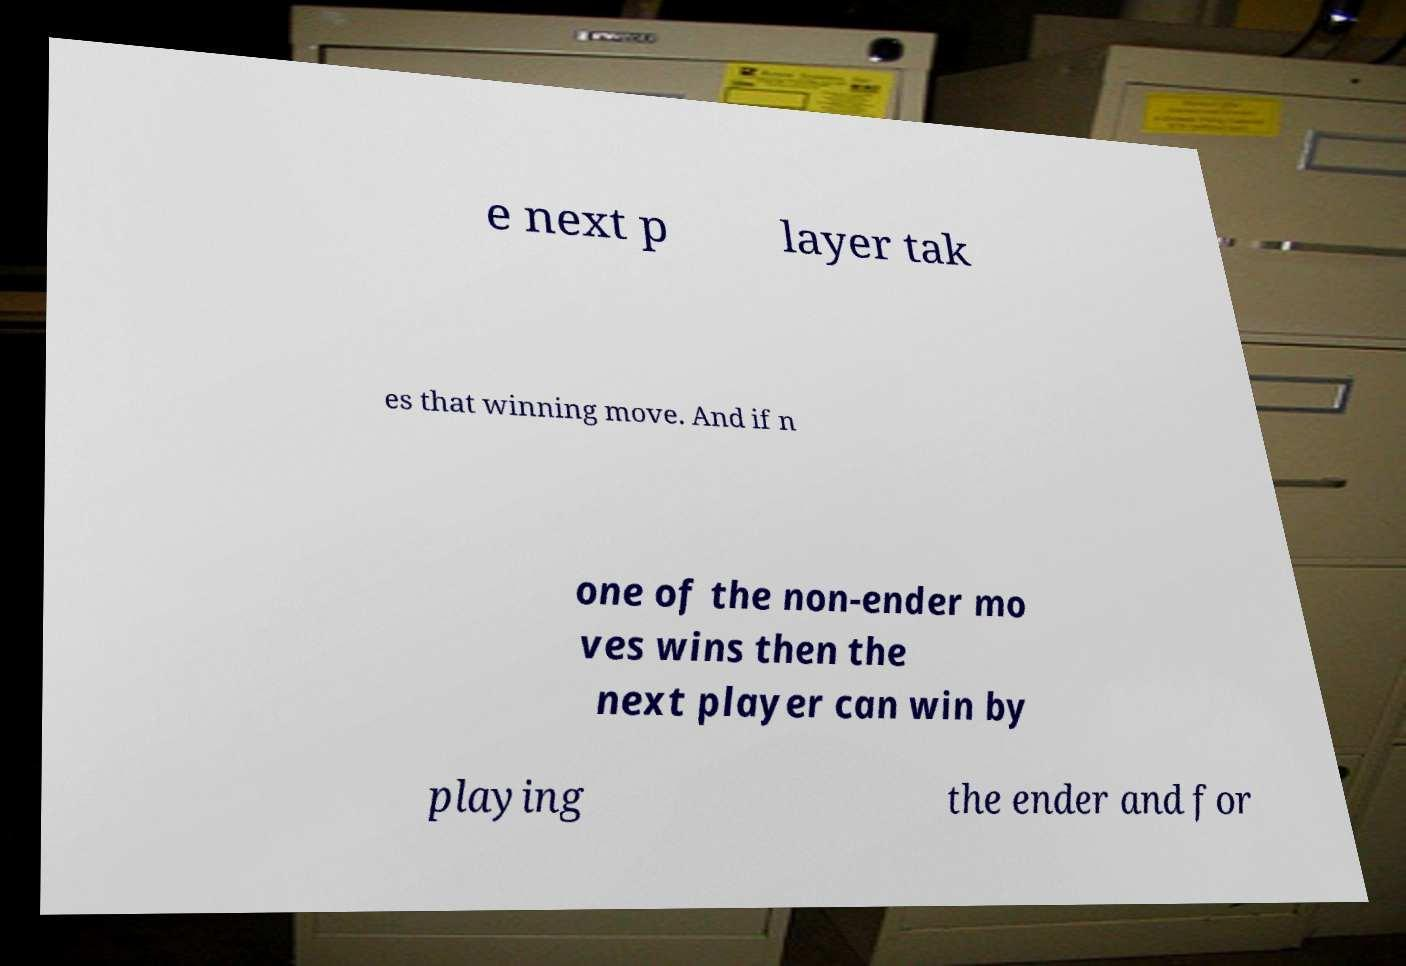Could you extract and type out the text from this image? e next p layer tak es that winning move. And if n one of the non-ender mo ves wins then the next player can win by playing the ender and for 